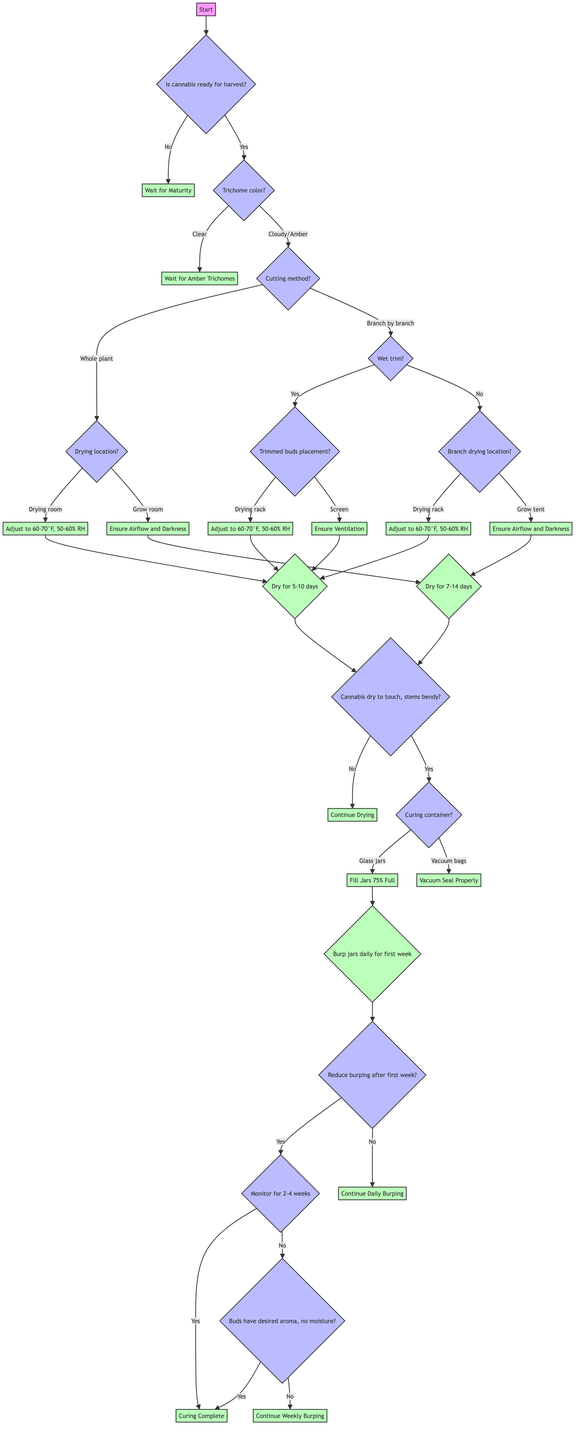Is the first step to check if the cannabis is ready for harvest? Yes, the first node in the diagram is labeled "Start" and directly leads to the question "Is the cannabis ready for harvest?"
Answer: Yes What happens if the cannabis is not ready for harvest? If the cannabis is not ready for harvest, the flow leads to "Wait for Maturity," indicating that you need to give it more time before proceeding.
Answer: Wait for Maturity How many methods are there for cutting cannabis according to the diagram? The diagram shows two options under the "Cutting method" question: "Cut Entire Plant" and "Cut Individual Branches," which means there are two methods.
Answer: Two What is the drying temperature and humidity if drying in a climate-controlled room? When drying in a climate-controlled room, the adjustment is to 60-70°F with 50-60% relative humidity, as specified in the diagram.
Answer: 60-70°F, 50-60% RH What should you do if the cannabis is dry to touch but stems are still bendy? The flow from "Monitor for Desired Dryness" to "Proceed to Curing" indicates that you should proceed to the curing stage when this condition is met.
Answer: Proceed to Curing How often should you burp jars in the first week? The diagram states that you should open jars for 10-15 minutes daily during the first week of curing after filling glass jars 75% full.
Answer: Daily What is the next step after reducing burping frequency? The next step after reducing burping frequency is to monitor for 2-4 weeks for curing completion per the diagram flow.
Answer: Monitor for 2-4 weeks If you have vacuum-seal bags for curing, what do you need to do? The diagram specifies that if using vacuum-seal bags, you should "Vacuum Seal Properly," which is the action that needs to be taken.
Answer: Vacuum Seal Properly What should you do if buds have the desired aroma and no moisture during the curing process? If buds have the desired aroma and no moisture, it indicates "Curing Complete," according to the decision point in the diagram.
Answer: Curing Complete 